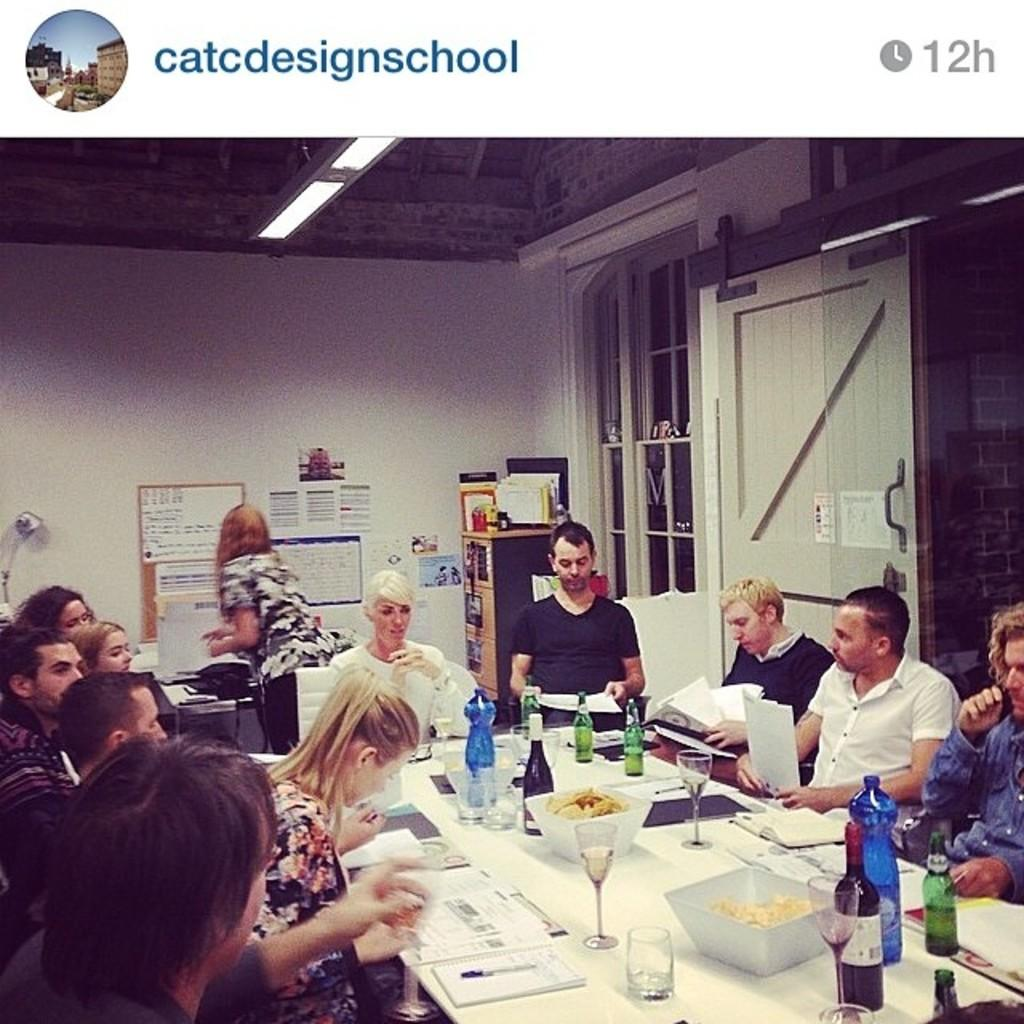How many people are in the image? There is a group of people in the image, but the exact number is not specified. What are the people doing in the image? The people are sitting at a table in the image. What can be found on the table in the image? There is food, wine bottles, and water bottles on the table in the image. What type of cord is being used to tie the deer in the image? There is no deer or cord present in the image; it features a group of people sitting at a table with food, wine bottles, and water bottles. 